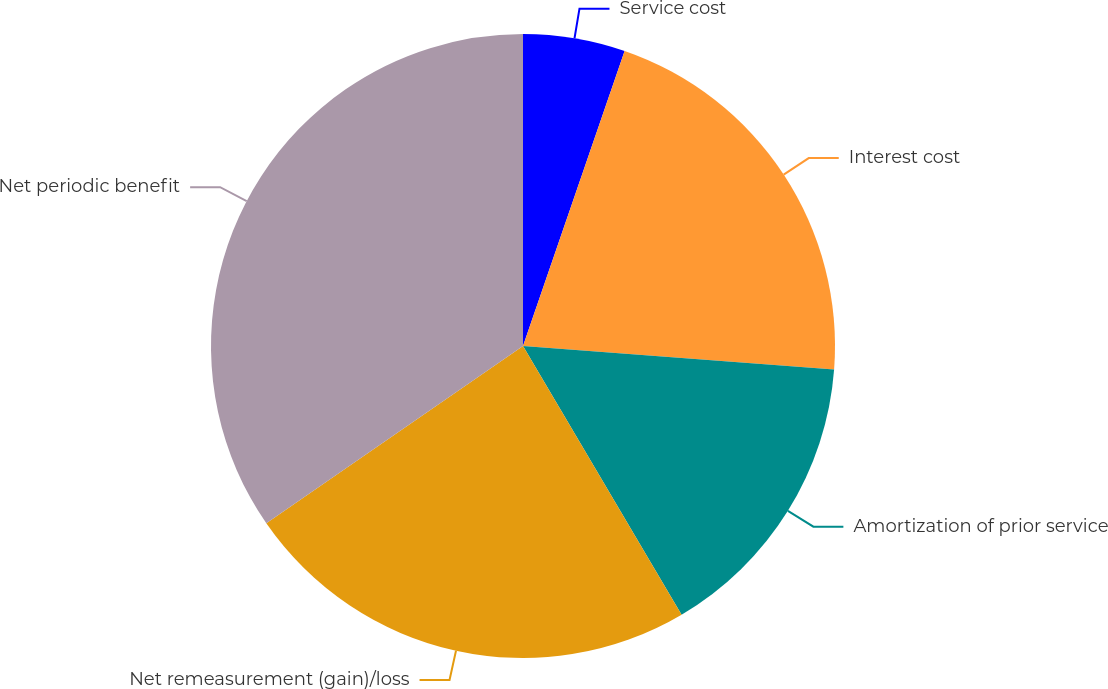Convert chart to OTSL. <chart><loc_0><loc_0><loc_500><loc_500><pie_chart><fcel>Service cost<fcel>Interest cost<fcel>Amortization of prior service<fcel>Net remeasurement (gain)/loss<fcel>Net periodic benefit<nl><fcel>5.28%<fcel>20.92%<fcel>15.31%<fcel>23.86%<fcel>34.62%<nl></chart> 